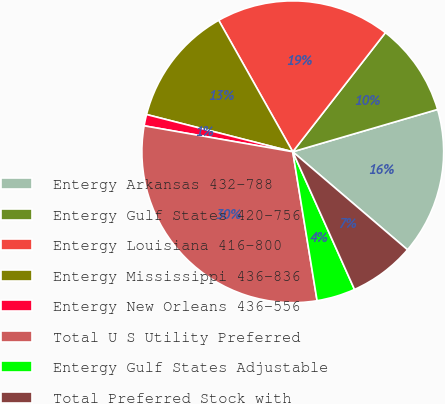Convert chart to OTSL. <chart><loc_0><loc_0><loc_500><loc_500><pie_chart><fcel>Entergy Arkansas 432-788<fcel>Entergy Gulf States 420-756<fcel>Entergy Louisiana 416-800<fcel>Entergy Mississippi 436-836<fcel>Entergy New Orleans 436-556<fcel>Total U S Utility Preferred<fcel>Entergy Gulf States Adjustable<fcel>Total Preferred Stock with<nl><fcel>15.77%<fcel>9.95%<fcel>18.68%<fcel>12.86%<fcel>1.22%<fcel>30.32%<fcel>4.13%<fcel>7.04%<nl></chart> 